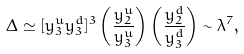Convert formula to latex. <formula><loc_0><loc_0><loc_500><loc_500>\Delta \simeq [ y ^ { u } _ { 3 } y ^ { d } _ { 3 } ] ^ { 3 } \left ( \frac { y ^ { u } _ { 2 } } { y ^ { u } _ { 3 } } \right ) \left ( \frac { y ^ { d } _ { 2 } } { y ^ { d } _ { 3 } } \right ) \sim \lambda ^ { 7 } ,</formula> 